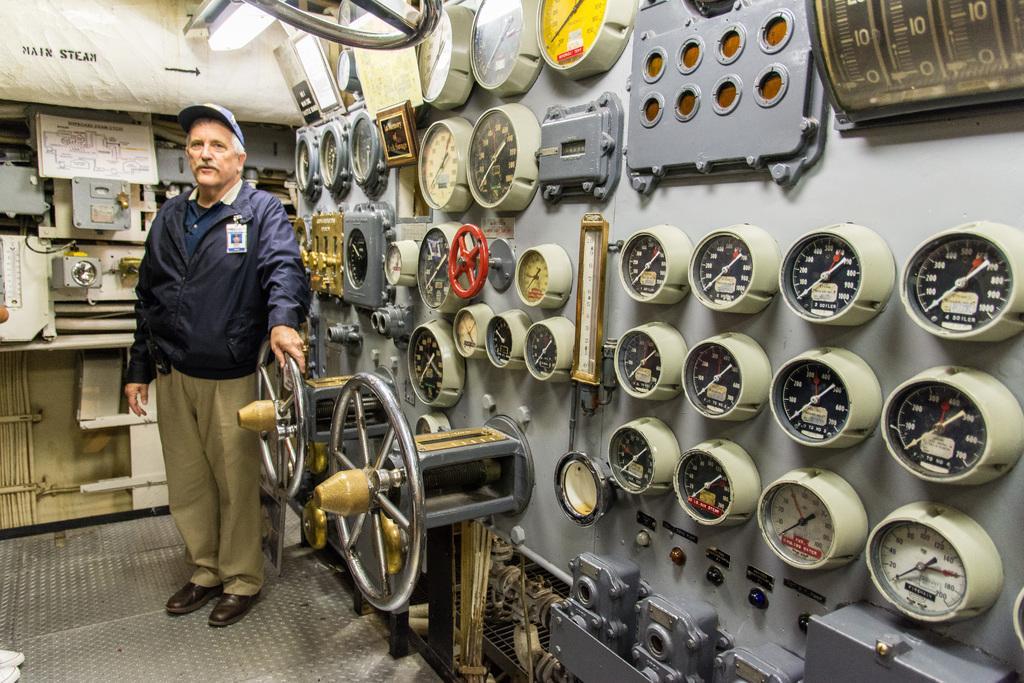In one or two sentences, can you explain what this image depicts? This image consists of a man wearing blue jacket. It looks like it is clicked in a ship. At the bottom, there is a floor. To the right, there is a steering. 